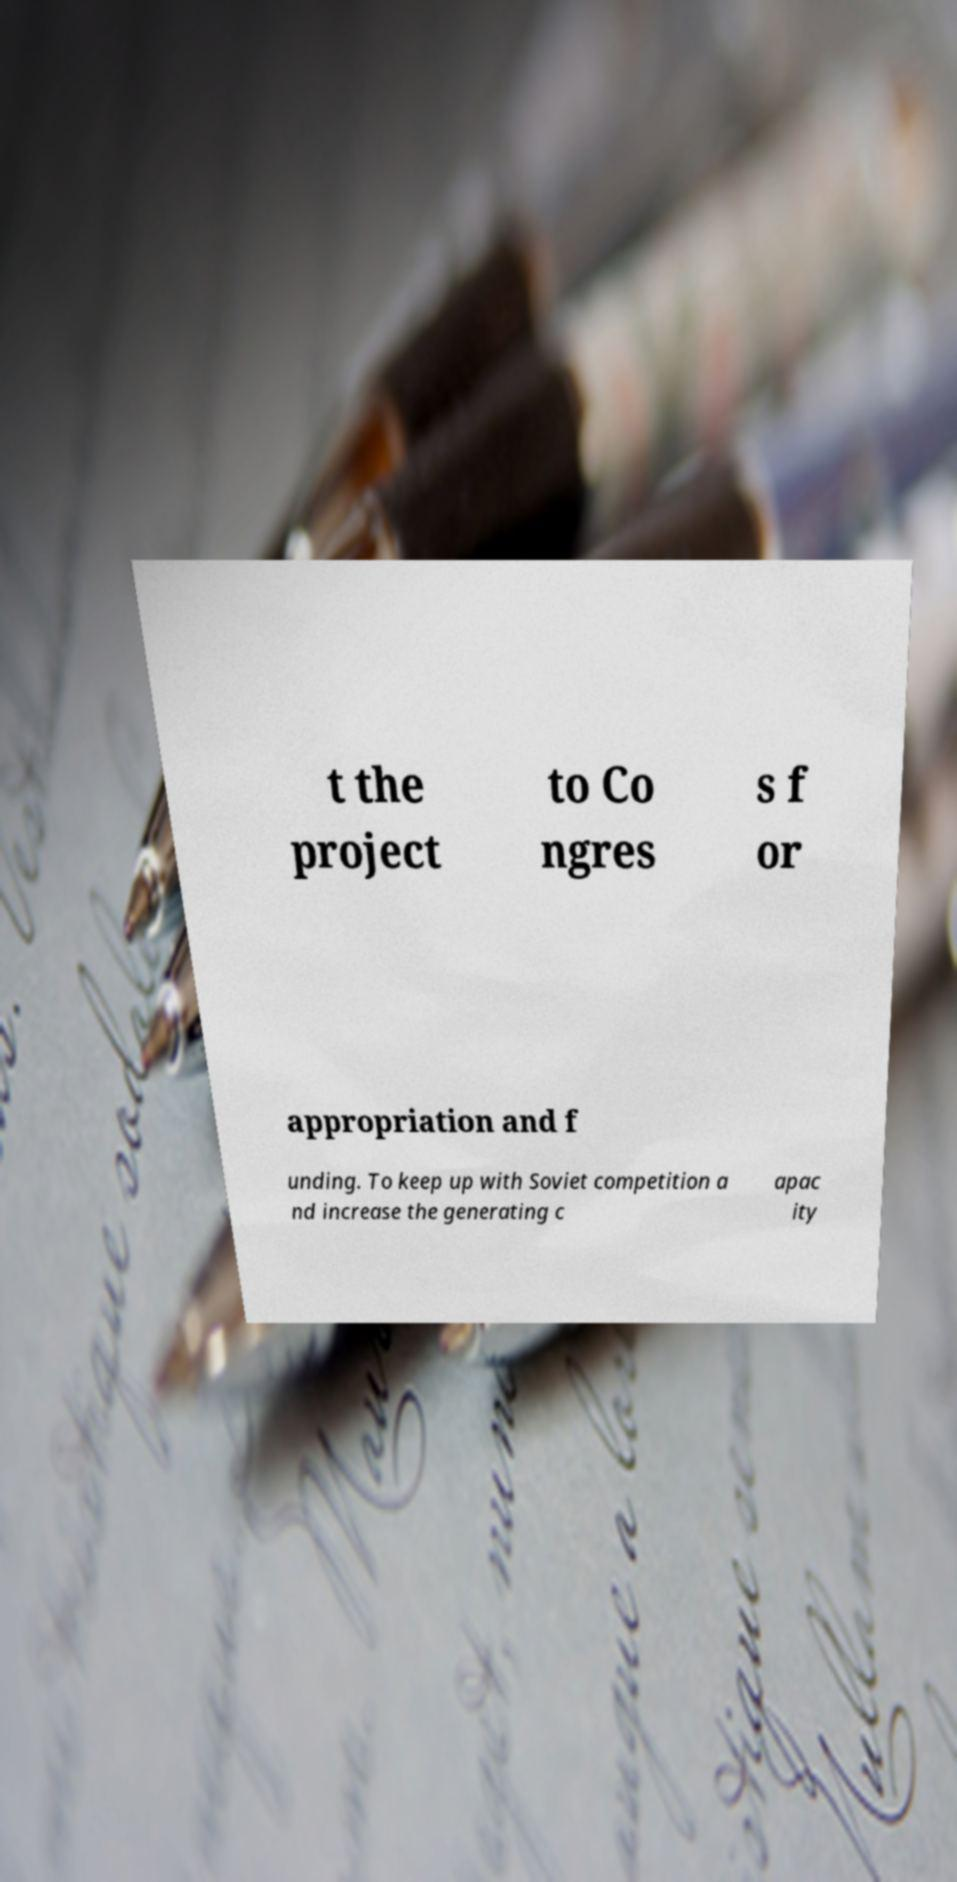What messages or text are displayed in this image? I need them in a readable, typed format. t the project to Co ngres s f or appropriation and f unding. To keep up with Soviet competition a nd increase the generating c apac ity 